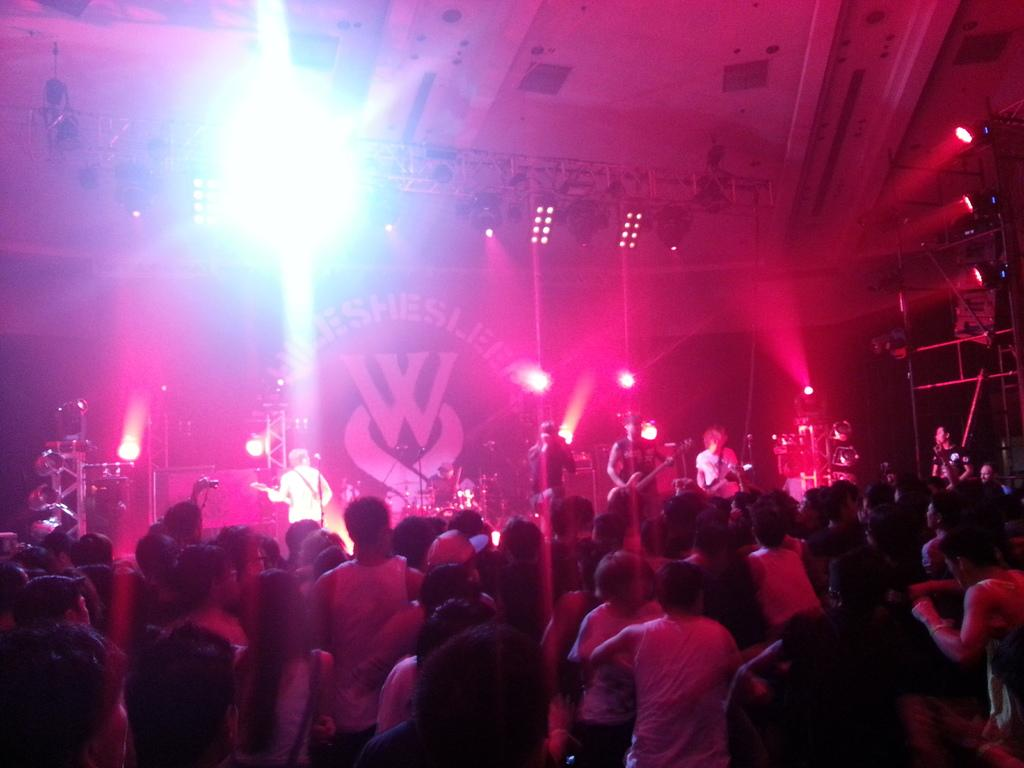What is happening in the image involving a group of people? There is a group of people standing in the image, and people are playing musical instruments in front of the group. What can be seen on the stage where the group is standing? There are many lights on the stage. What degree of intensity is the earthquake in the image? There is no earthquake present in the image. Can you provide a list of all the musical instruments being played in the image? Based on the provided facts, we know that people are playing musical instruments in front of the group, but we cannot provide a list of specific instruments without additional information. 